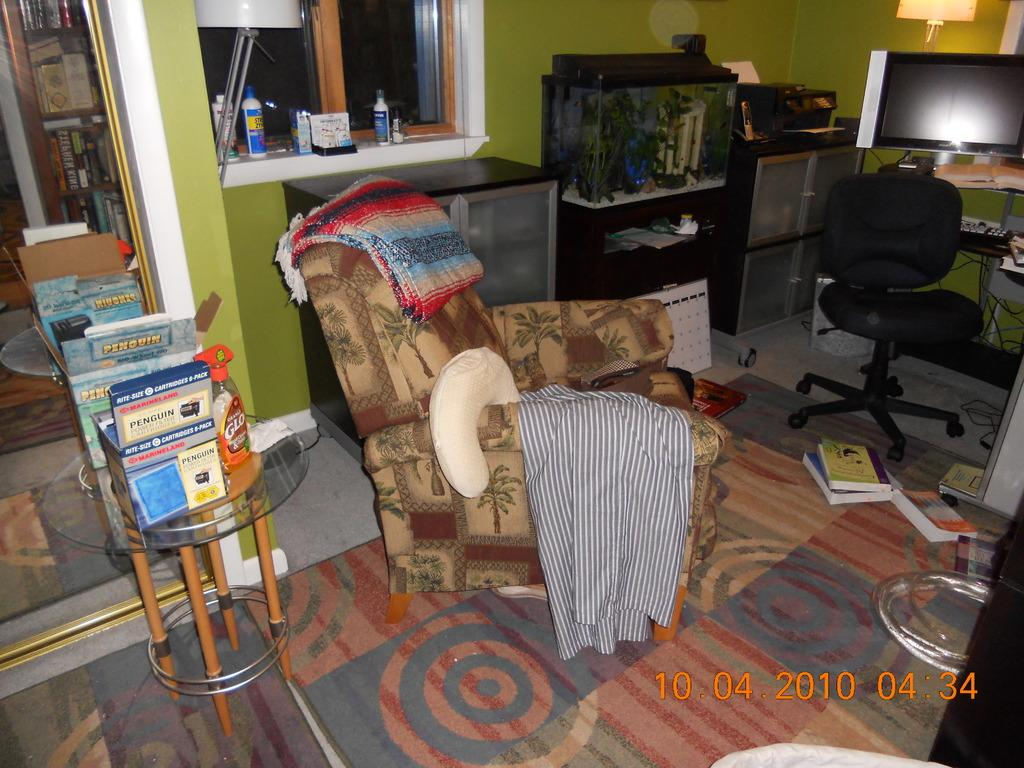<image>
Provide a brief description of the given image. A living room with a comfy couch and blankets and several Penguin books on a stand. 